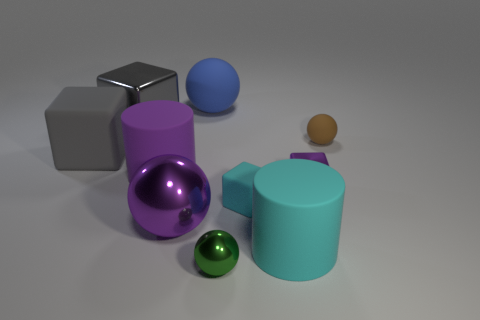There is a tiny metallic thing that is behind the green object; is its shape the same as the blue rubber thing?
Your answer should be compact. No. The tiny metallic block has what color?
Offer a terse response. Purple. The large rubber object that is the same color as the large shiny ball is what shape?
Provide a succinct answer. Cylinder. Are there any large cubes?
Your answer should be compact. Yes. What is the size of the gray object that is made of the same material as the tiny brown ball?
Provide a short and direct response. Large. What is the shape of the small object that is in front of the big sphere in front of the tiny object that is behind the gray rubber object?
Your answer should be very brief. Sphere. Is the number of large matte cylinders that are behind the gray metal cube the same as the number of small gray things?
Your response must be concise. Yes. The rubber object that is the same color as the small rubber block is what size?
Provide a short and direct response. Large. Does the small purple metal thing have the same shape as the green object?
Ensure brevity in your answer.  No. How many objects are either rubber balls that are right of the small green shiny ball or big cyan matte blocks?
Offer a terse response. 1. 